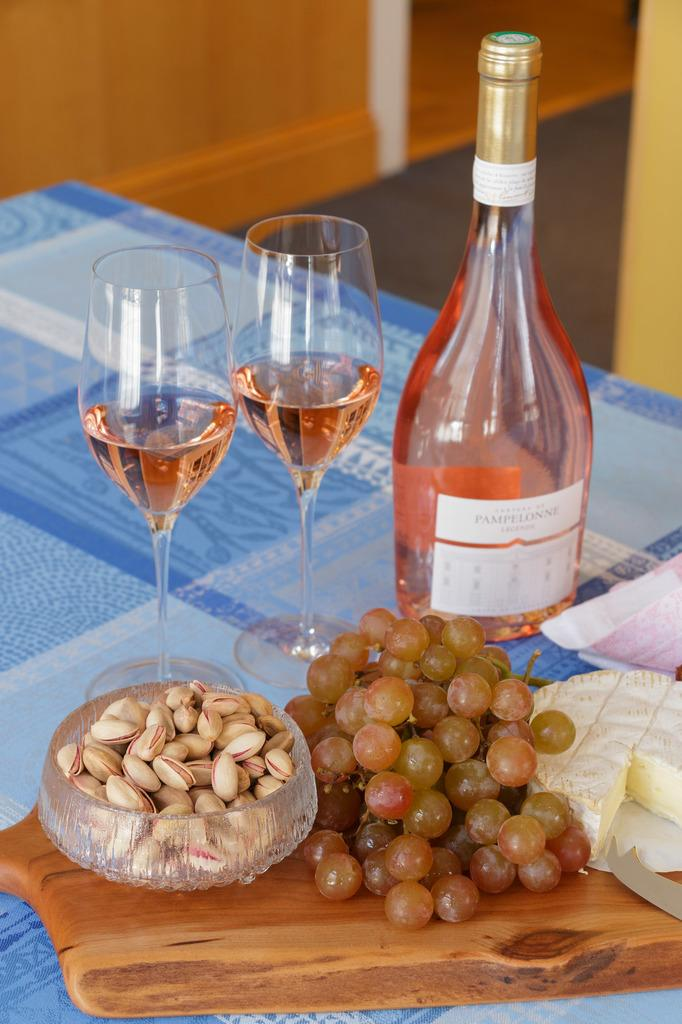What is the main piece of furniture in the image? There is a table in the image. What items can be seen on the table? There are two wine glasses, a bottle, grapes, a cake, peanuts, and a tissue on the table. What color is the wall in the background of the image? There is a red color wall in the background of the image. What type of glass is used to make the aftermath of the party in the image? There is no aftermath of a party present in the image, and therefore no glass can be associated with it. 